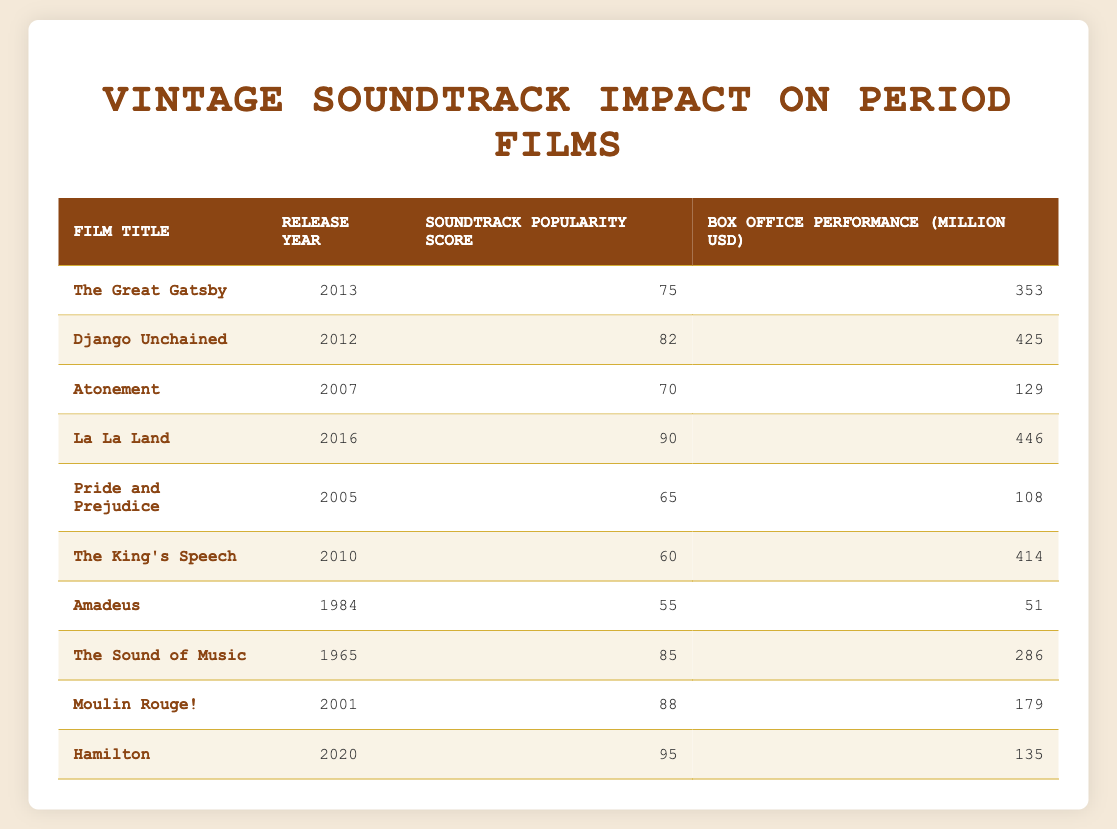What is the box office performance of "La La Land"? The table shows that "La La Land" has a box office performance of 446 million USD listed under the corresponding column for that film title.
Answer: 446 Which film has the highest soundtrack popularity score? By reviewing the soundtrack popularity scores, "Hamilton" has the highest score of 95 among all films in the table, when sorted in descending order of popularity scores.
Answer: Hamilton What is the average box office performance of films released after the year 2010? The films released after 2010 in the table are "Django Unchained", "The King's Speech", "La La Land", and "Hamilton", with box office values of 425, 414, 446, and 135 million USD respectively. Summing these gives 425 + 414 + 446 + 135 = 1420. There are 4 films, so the average is 1420 / 4 = 355.
Answer: 355 Is "Amadeus" soundtrack popularity score higher than that of "Pride and Prejudice"? "Amadeus" has a soundtrack popularity score of 55 and "Pride and Prejudice" has a score of 65. Since 55 is less than 65, the answer is no.
Answer: No Total the box office performance of films with a soundtrack popularity score above 80. The films with a popularity score above 80 are "Django Unchained" (425), "La La Land" (446), "Hamilton" (135), and "Moulin Rouge!" (179). Adding these gives 425 + 446 + 135 + 179 = 1185 million USD.
Answer: 1185 Which film released before the year 2000 has the best box office performance? The table lists "The Sound of Music" (286 million USD) and "Amadeus" (51 million USD) as films before 2000. Comparing their box office values, "The Sound of Music" surpassed "Amadeus", showing it had the better performance.
Answer: The Sound of Music How many films have a box office performance greater than 300 million USD? By checking the table, the films that exceed this threshold are "The Great Gatsby" (353), "Django Unchained" (425), "La La Land" (446), and "The King's Speech" (414), making a total of 4 films.
Answer: 4 Is the average soundtrack popularity score of the films released before 2010 higher than 75? The films before 2010 are "Amadeus", "The Sound of Music", "Pride and Prejudice", "Atonement", and "The King's Speech". Their scores are 55, 85, 65, 70, and 60 respectively. Calculating the average: (55 + 85 + 65 + 70 + 60) = 335 and there are 5 films, hence the average is 335 / 5 = 67. Since 67 is less than 75, the answer is no.
Answer: No What was the box office performance difference between "The King's Speech" and "Moulin Rouge!"? "The King's Speech" made 414 million USD and "Moulin Rouge!" made 179 million USD. Calculating the difference gives 414 - 179 = 235 million USD. Therefore, the box office performance difference is 235 million USD.
Answer: 235 